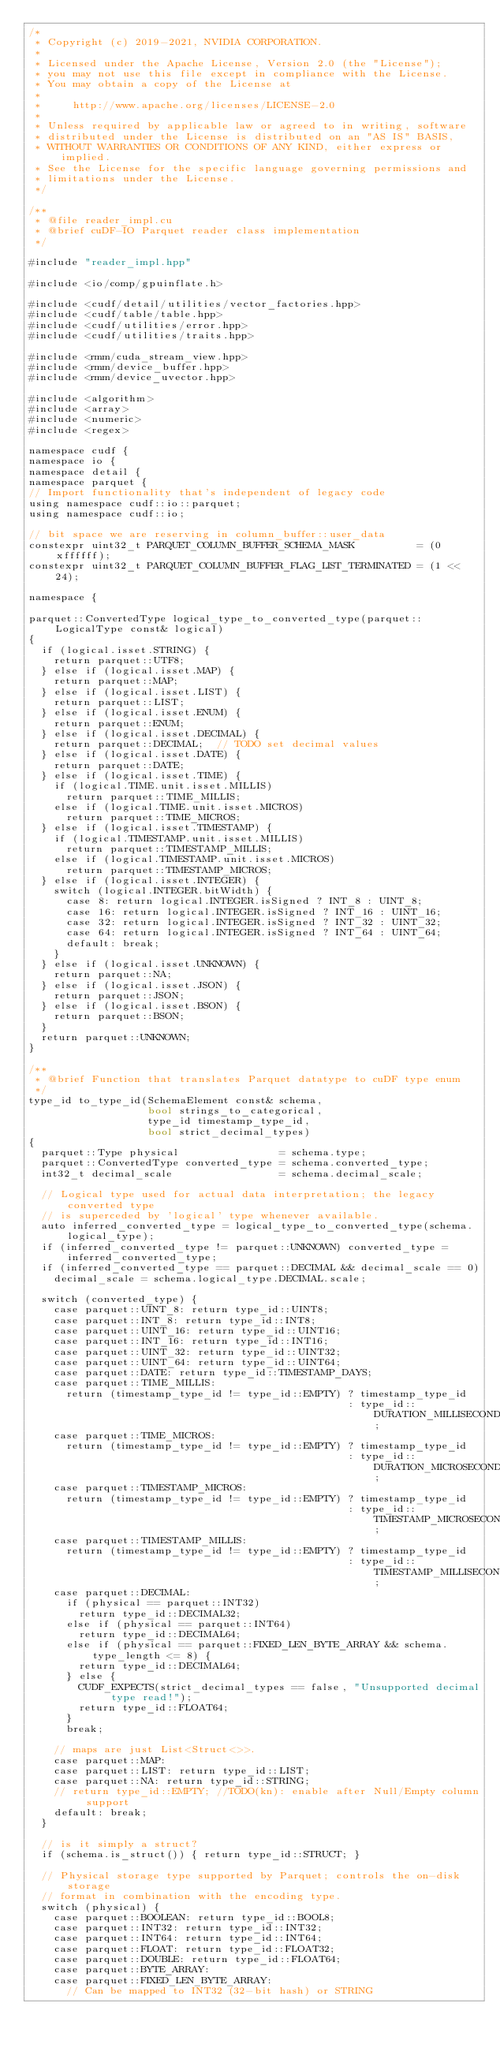Convert code to text. <code><loc_0><loc_0><loc_500><loc_500><_Cuda_>/*
 * Copyright (c) 2019-2021, NVIDIA CORPORATION.
 *
 * Licensed under the Apache License, Version 2.0 (the "License");
 * you may not use this file except in compliance with the License.
 * You may obtain a copy of the License at
 *
 *     http://www.apache.org/licenses/LICENSE-2.0
 *
 * Unless required by applicable law or agreed to in writing, software
 * distributed under the License is distributed on an "AS IS" BASIS,
 * WITHOUT WARRANTIES OR CONDITIONS OF ANY KIND, either express or implied.
 * See the License for the specific language governing permissions and
 * limitations under the License.
 */

/**
 * @file reader_impl.cu
 * @brief cuDF-IO Parquet reader class implementation
 */

#include "reader_impl.hpp"

#include <io/comp/gpuinflate.h>

#include <cudf/detail/utilities/vector_factories.hpp>
#include <cudf/table/table.hpp>
#include <cudf/utilities/error.hpp>
#include <cudf/utilities/traits.hpp>

#include <rmm/cuda_stream_view.hpp>
#include <rmm/device_buffer.hpp>
#include <rmm/device_uvector.hpp>

#include <algorithm>
#include <array>
#include <numeric>
#include <regex>

namespace cudf {
namespace io {
namespace detail {
namespace parquet {
// Import functionality that's independent of legacy code
using namespace cudf::io::parquet;
using namespace cudf::io;

// bit space we are reserving in column_buffer::user_data
constexpr uint32_t PARQUET_COLUMN_BUFFER_SCHEMA_MASK          = (0xffffff);
constexpr uint32_t PARQUET_COLUMN_BUFFER_FLAG_LIST_TERMINATED = (1 << 24);

namespace {

parquet::ConvertedType logical_type_to_converted_type(parquet::LogicalType const& logical)
{
  if (logical.isset.STRING) {
    return parquet::UTF8;
  } else if (logical.isset.MAP) {
    return parquet::MAP;
  } else if (logical.isset.LIST) {
    return parquet::LIST;
  } else if (logical.isset.ENUM) {
    return parquet::ENUM;
  } else if (logical.isset.DECIMAL) {
    return parquet::DECIMAL;  // TODO set decimal values
  } else if (logical.isset.DATE) {
    return parquet::DATE;
  } else if (logical.isset.TIME) {
    if (logical.TIME.unit.isset.MILLIS)
      return parquet::TIME_MILLIS;
    else if (logical.TIME.unit.isset.MICROS)
      return parquet::TIME_MICROS;
  } else if (logical.isset.TIMESTAMP) {
    if (logical.TIMESTAMP.unit.isset.MILLIS)
      return parquet::TIMESTAMP_MILLIS;
    else if (logical.TIMESTAMP.unit.isset.MICROS)
      return parquet::TIMESTAMP_MICROS;
  } else if (logical.isset.INTEGER) {
    switch (logical.INTEGER.bitWidth) {
      case 8: return logical.INTEGER.isSigned ? INT_8 : UINT_8;
      case 16: return logical.INTEGER.isSigned ? INT_16 : UINT_16;
      case 32: return logical.INTEGER.isSigned ? INT_32 : UINT_32;
      case 64: return logical.INTEGER.isSigned ? INT_64 : UINT_64;
      default: break;
    }
  } else if (logical.isset.UNKNOWN) {
    return parquet::NA;
  } else if (logical.isset.JSON) {
    return parquet::JSON;
  } else if (logical.isset.BSON) {
    return parquet::BSON;
  }
  return parquet::UNKNOWN;
}

/**
 * @brief Function that translates Parquet datatype to cuDF type enum
 */
type_id to_type_id(SchemaElement const& schema,
                   bool strings_to_categorical,
                   type_id timestamp_type_id,
                   bool strict_decimal_types)
{
  parquet::Type physical                = schema.type;
  parquet::ConvertedType converted_type = schema.converted_type;
  int32_t decimal_scale                 = schema.decimal_scale;

  // Logical type used for actual data interpretation; the legacy converted type
  // is superceded by 'logical' type whenever available.
  auto inferred_converted_type = logical_type_to_converted_type(schema.logical_type);
  if (inferred_converted_type != parquet::UNKNOWN) converted_type = inferred_converted_type;
  if (inferred_converted_type == parquet::DECIMAL && decimal_scale == 0)
    decimal_scale = schema.logical_type.DECIMAL.scale;

  switch (converted_type) {
    case parquet::UINT_8: return type_id::UINT8;
    case parquet::INT_8: return type_id::INT8;
    case parquet::UINT_16: return type_id::UINT16;
    case parquet::INT_16: return type_id::INT16;
    case parquet::UINT_32: return type_id::UINT32;
    case parquet::UINT_64: return type_id::UINT64;
    case parquet::DATE: return type_id::TIMESTAMP_DAYS;
    case parquet::TIME_MILLIS:
      return (timestamp_type_id != type_id::EMPTY) ? timestamp_type_id
                                                   : type_id::DURATION_MILLISECONDS;
    case parquet::TIME_MICROS:
      return (timestamp_type_id != type_id::EMPTY) ? timestamp_type_id
                                                   : type_id::DURATION_MICROSECONDS;
    case parquet::TIMESTAMP_MICROS:
      return (timestamp_type_id != type_id::EMPTY) ? timestamp_type_id
                                                   : type_id::TIMESTAMP_MICROSECONDS;
    case parquet::TIMESTAMP_MILLIS:
      return (timestamp_type_id != type_id::EMPTY) ? timestamp_type_id
                                                   : type_id::TIMESTAMP_MILLISECONDS;
    case parquet::DECIMAL:
      if (physical == parquet::INT32)
        return type_id::DECIMAL32;
      else if (physical == parquet::INT64)
        return type_id::DECIMAL64;
      else if (physical == parquet::FIXED_LEN_BYTE_ARRAY && schema.type_length <= 8) {
        return type_id::DECIMAL64;
      } else {
        CUDF_EXPECTS(strict_decimal_types == false, "Unsupported decimal type read!");
        return type_id::FLOAT64;
      }
      break;

    // maps are just List<Struct<>>.
    case parquet::MAP:
    case parquet::LIST: return type_id::LIST;
    case parquet::NA: return type_id::STRING;
    // return type_id::EMPTY; //TODO(kn): enable after Null/Empty column support
    default: break;
  }

  // is it simply a struct?
  if (schema.is_struct()) { return type_id::STRUCT; }

  // Physical storage type supported by Parquet; controls the on-disk storage
  // format in combination with the encoding type.
  switch (physical) {
    case parquet::BOOLEAN: return type_id::BOOL8;
    case parquet::INT32: return type_id::INT32;
    case parquet::INT64: return type_id::INT64;
    case parquet::FLOAT: return type_id::FLOAT32;
    case parquet::DOUBLE: return type_id::FLOAT64;
    case parquet::BYTE_ARRAY:
    case parquet::FIXED_LEN_BYTE_ARRAY:
      // Can be mapped to INT32 (32-bit hash) or STRING</code> 